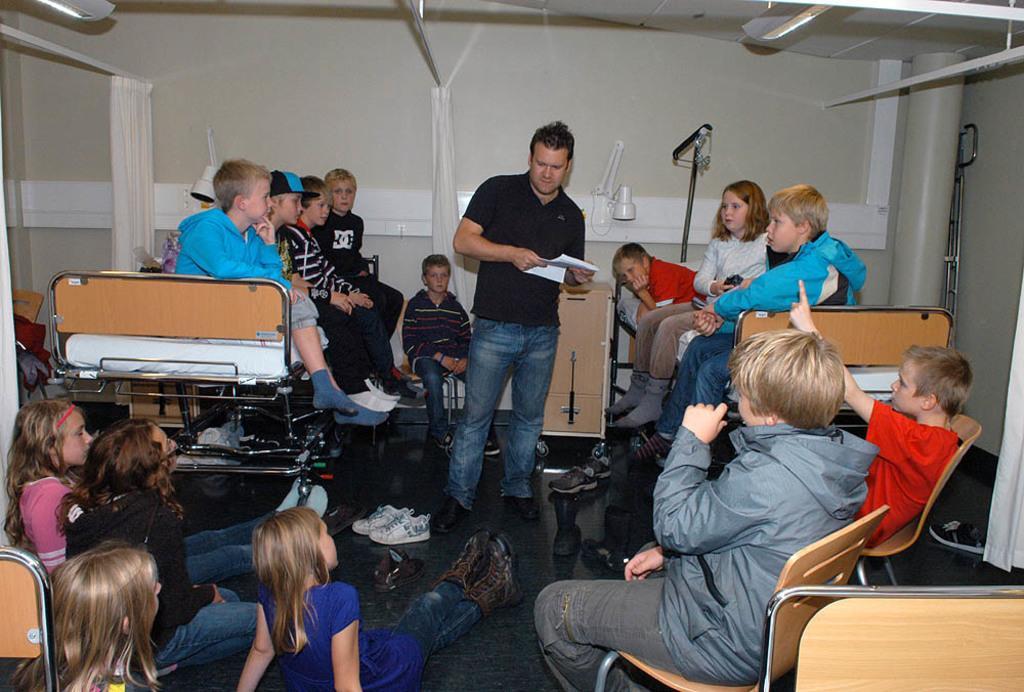Describe this image in one or two sentences. In this image I can see a group of kids and a man, all the kids are sitting on the beds in the chairs and some of them are lying on the floor facing towards the person standing in the center of the image. I can see some wooden chairs, two beds, a wooden cupboard, some lights, curtains, and a pillar on the right hand side. Among this group of people some of them are removed their shoes I can see them on floor. 